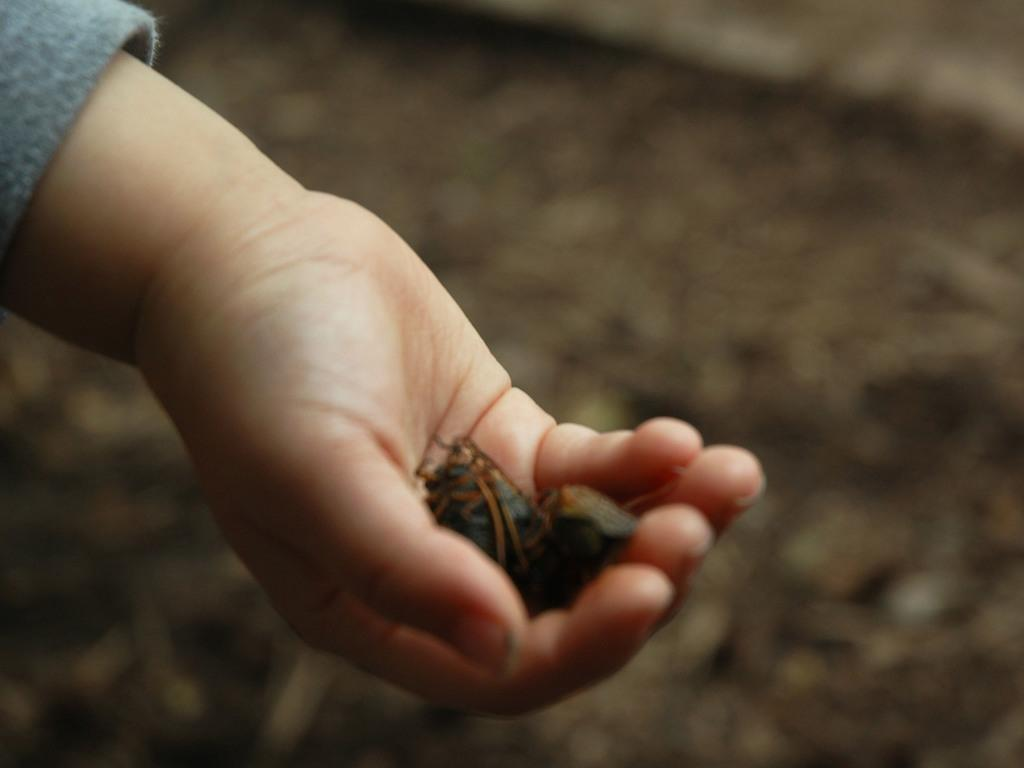What is in the hand of the person in the image? There are insects in the hand of a person. Can you describe the background of the image? The background of the image is blurred. What type of smile can be seen on the wrist of the person in the image? There is no smile visible on the wrist of the person in the image. What type of furniture is present in the image? There is no furniture present in the image. 